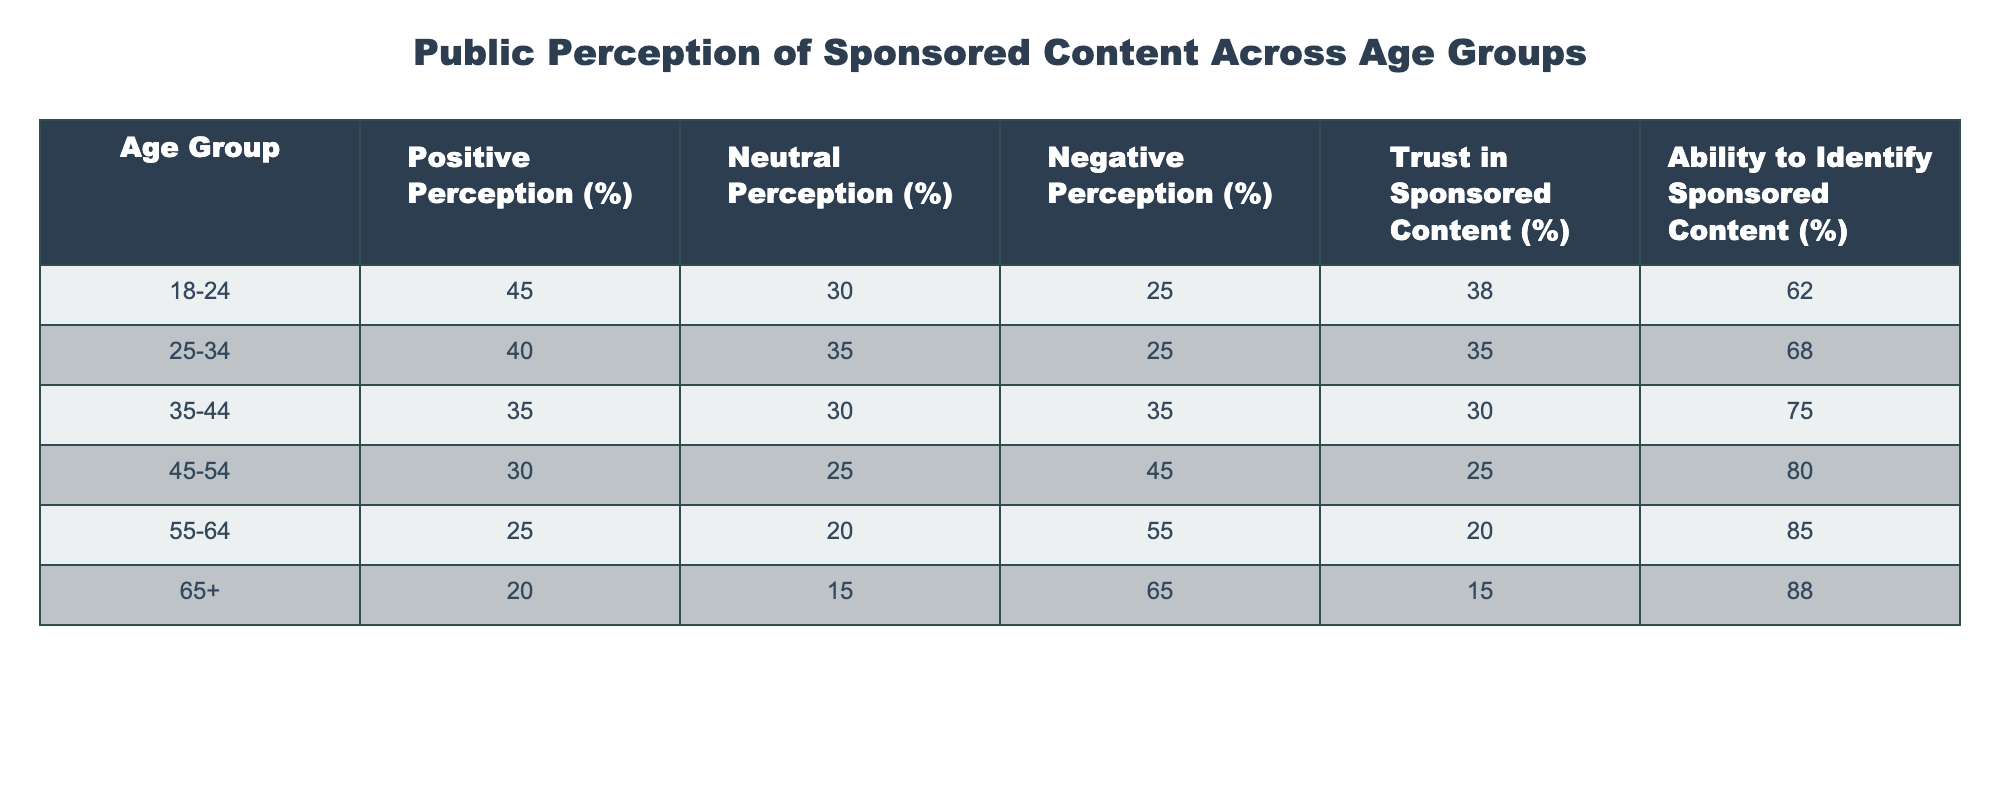What percentage of the 18-24 age group has a positive perception of sponsored content? The table indicates that 45% of the 18-24 age group has a positive perception of sponsored content.
Answer: 45% Which age group shows the highest negative perception of sponsored content? The 65+ age group has the highest negative perception at 65%.
Answer: 65+ What is the average positive perception percentage across all age groups? The positive perception percentages for all age groups are 45, 40, 35, 30, 25, and 20. Adding them gives 195, and dividing by 6 results in an average of 32.5%.
Answer: 32.5% Is it true that the trust in sponsored content decreases with age? Looking at the trust percentages (38, 35, 30, 25, 20, 15), it is clear that trust decreases as age increases. Therefore, the statement is true.
Answer: True Which age group has the highest ability to identify sponsored content, and what percentage does it represent? The 65+ age group has the highest ability to identify sponsored content at 88%.
Answer: 88% What is the difference in neutral perception between the 25-34 and 45-54 age groups? Neutral perception for the 25-34 age group is 35%, while for the 45-54 group is 25%. The difference is 35% - 25% = 10%.
Answer: 10% What percentage of the 55-64 age group has a negative perception of sponsored content, and how does it compare to the 25-34 age group? The 55-64 age group has a negative perception of 55%, compared to 25% in the 25-34 age group. This shows a difference of 30%, with the 55-64 group being higher.
Answer: 55%, 30% higher Across all age groups, which has the least trust in sponsored content, and how much lower is it compared to the 18-24 age group? The 65+ age group has the least trust in sponsored content at 15%, which is 23% lower than the 18-24 age group, which has 38%.
Answer: 15%, 23% lower How does the positive perception of sponsored content in the 35-44 age group compare to that in the 55-64 age group? The 35-44 age group has a positive perception of 35%, while the 55-64 age group has 25%. The 35-44 group has a 10% higher positive perception.
Answer: 10% higher What is the trend in neutral perception as age increases from 18-24 to 65+? The table shows that neutral perception declines from 30% in the 18-24 age group to 15% in the 65+ age group, indicating an overall decreasing trend.
Answer: Decreasing trend 